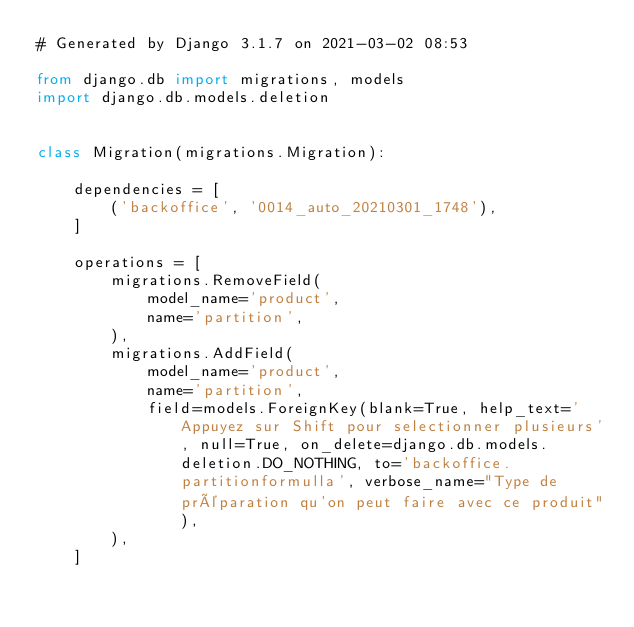<code> <loc_0><loc_0><loc_500><loc_500><_Python_># Generated by Django 3.1.7 on 2021-03-02 08:53

from django.db import migrations, models
import django.db.models.deletion


class Migration(migrations.Migration):

    dependencies = [
        ('backoffice', '0014_auto_20210301_1748'),
    ]

    operations = [
        migrations.RemoveField(
            model_name='product',
            name='partition',
        ),
        migrations.AddField(
            model_name='product',
            name='partition',
            field=models.ForeignKey(blank=True, help_text='Appuyez sur Shift pour selectionner plusieurs', null=True, on_delete=django.db.models.deletion.DO_NOTHING, to='backoffice.partitionformulla', verbose_name="Type de préparation qu'on peut faire avec ce produit"),
        ),
    ]
</code> 